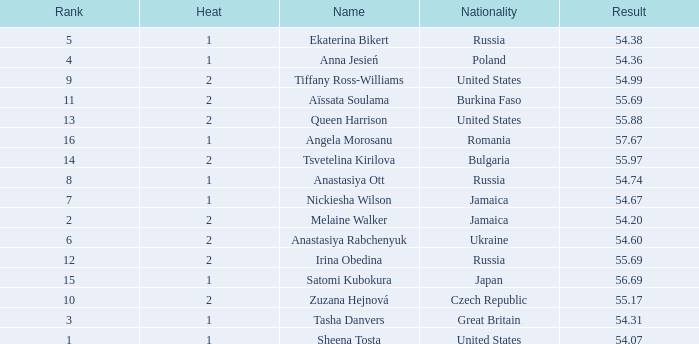Which Heat has a Nationality of bulgaria, and a Result larger than 55.97? None. 